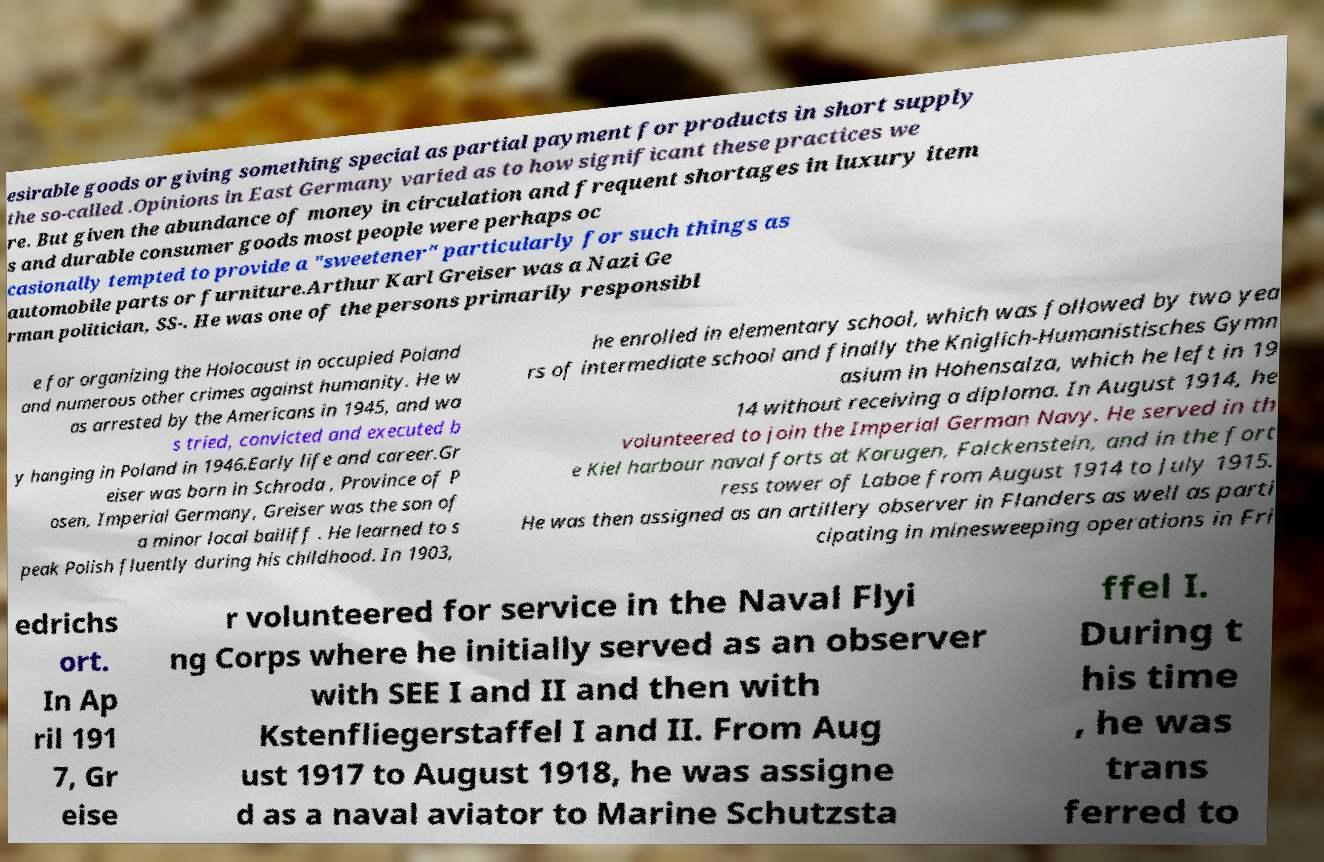What messages or text are displayed in this image? I need them in a readable, typed format. esirable goods or giving something special as partial payment for products in short supply the so-called .Opinions in East Germany varied as to how significant these practices we re. But given the abundance of money in circulation and frequent shortages in luxury item s and durable consumer goods most people were perhaps oc casionally tempted to provide a "sweetener" particularly for such things as automobile parts or furniture.Arthur Karl Greiser was a Nazi Ge rman politician, SS-. He was one of the persons primarily responsibl e for organizing the Holocaust in occupied Poland and numerous other crimes against humanity. He w as arrested by the Americans in 1945, and wa s tried, convicted and executed b y hanging in Poland in 1946.Early life and career.Gr eiser was born in Schroda , Province of P osen, Imperial Germany, Greiser was the son of a minor local bailiff . He learned to s peak Polish fluently during his childhood. In 1903, he enrolled in elementary school, which was followed by two yea rs of intermediate school and finally the Kniglich-Humanistisches Gymn asium in Hohensalza, which he left in 19 14 without receiving a diploma. In August 1914, he volunteered to join the Imperial German Navy. He served in th e Kiel harbour naval forts at Korugen, Falckenstein, and in the fort ress tower of Laboe from August 1914 to July 1915. He was then assigned as an artillery observer in Flanders as well as parti cipating in minesweeping operations in Fri edrichs ort. In Ap ril 191 7, Gr eise r volunteered for service in the Naval Flyi ng Corps where he initially served as an observer with SEE I and II and then with Kstenfliegerstaffel I and II. From Aug ust 1917 to August 1918, he was assigne d as a naval aviator to Marine Schutzsta ffel I. During t his time , he was trans ferred to 